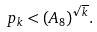<formula> <loc_0><loc_0><loc_500><loc_500>p _ { k } < ( A _ { 8 } ) ^ { \sqrt { k } } .</formula> 